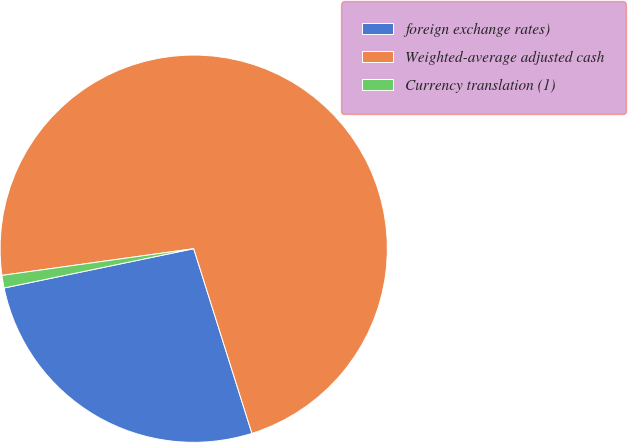Convert chart. <chart><loc_0><loc_0><loc_500><loc_500><pie_chart><fcel>foreign exchange rates)<fcel>Weighted-average adjusted cash<fcel>Currency translation (1)<nl><fcel>26.61%<fcel>72.34%<fcel>1.05%<nl></chart> 